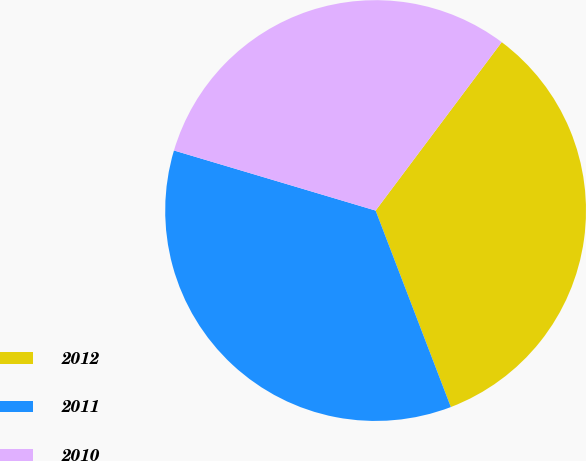<chart> <loc_0><loc_0><loc_500><loc_500><pie_chart><fcel>2012<fcel>2011<fcel>2010<nl><fcel>33.95%<fcel>35.43%<fcel>30.62%<nl></chart> 